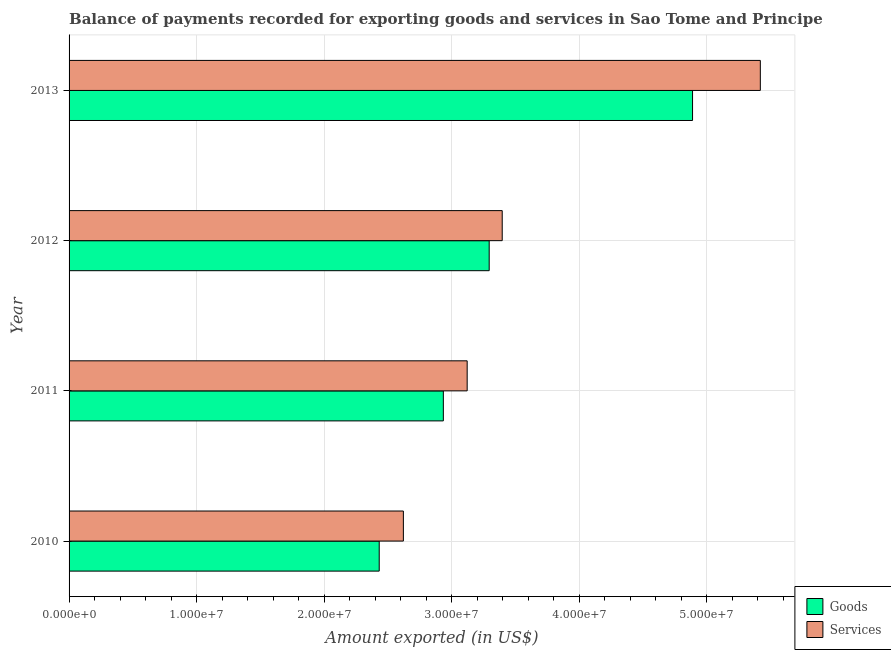How many groups of bars are there?
Provide a succinct answer. 4. Are the number of bars on each tick of the Y-axis equal?
Provide a short and direct response. Yes. How many bars are there on the 4th tick from the top?
Offer a very short reply. 2. How many bars are there on the 4th tick from the bottom?
Provide a short and direct response. 2. What is the label of the 3rd group of bars from the top?
Make the answer very short. 2011. In how many cases, is the number of bars for a given year not equal to the number of legend labels?
Keep it short and to the point. 0. What is the amount of goods exported in 2013?
Offer a very short reply. 4.89e+07. Across all years, what is the maximum amount of goods exported?
Your response must be concise. 4.89e+07. Across all years, what is the minimum amount of goods exported?
Your response must be concise. 2.43e+07. In which year was the amount of goods exported minimum?
Your response must be concise. 2010. What is the total amount of services exported in the graph?
Your response must be concise. 1.46e+08. What is the difference between the amount of services exported in 2010 and that in 2011?
Your answer should be compact. -5.00e+06. What is the difference between the amount of goods exported in 2013 and the amount of services exported in 2011?
Provide a succinct answer. 1.77e+07. What is the average amount of goods exported per year?
Ensure brevity in your answer.  3.39e+07. In the year 2011, what is the difference between the amount of goods exported and amount of services exported?
Provide a succinct answer. -1.87e+06. In how many years, is the amount of services exported greater than 18000000 US$?
Give a very brief answer. 4. What is the ratio of the amount of services exported in 2011 to that in 2012?
Offer a terse response. 0.92. Is the difference between the amount of goods exported in 2010 and 2011 greater than the difference between the amount of services exported in 2010 and 2011?
Your answer should be compact. No. What is the difference between the highest and the second highest amount of services exported?
Your answer should be compact. 2.02e+07. What is the difference between the highest and the lowest amount of goods exported?
Make the answer very short. 2.46e+07. Is the sum of the amount of goods exported in 2010 and 2011 greater than the maximum amount of services exported across all years?
Make the answer very short. No. What does the 2nd bar from the top in 2013 represents?
Make the answer very short. Goods. What does the 2nd bar from the bottom in 2013 represents?
Your answer should be very brief. Services. Are all the bars in the graph horizontal?
Make the answer very short. Yes. What is the difference between two consecutive major ticks on the X-axis?
Ensure brevity in your answer.  1.00e+07. Are the values on the major ticks of X-axis written in scientific E-notation?
Offer a very short reply. Yes. Does the graph contain grids?
Ensure brevity in your answer.  Yes. Where does the legend appear in the graph?
Ensure brevity in your answer.  Bottom right. What is the title of the graph?
Keep it short and to the point. Balance of payments recorded for exporting goods and services in Sao Tome and Principe. Does "Drinking water services" appear as one of the legend labels in the graph?
Offer a terse response. No. What is the label or title of the X-axis?
Keep it short and to the point. Amount exported (in US$). What is the Amount exported (in US$) in Goods in 2010?
Give a very brief answer. 2.43e+07. What is the Amount exported (in US$) in Services in 2010?
Your answer should be very brief. 2.62e+07. What is the Amount exported (in US$) in Goods in 2011?
Offer a very short reply. 2.93e+07. What is the Amount exported (in US$) of Services in 2011?
Offer a very short reply. 3.12e+07. What is the Amount exported (in US$) in Goods in 2012?
Offer a terse response. 3.29e+07. What is the Amount exported (in US$) of Services in 2012?
Your answer should be compact. 3.40e+07. What is the Amount exported (in US$) of Goods in 2013?
Ensure brevity in your answer.  4.89e+07. What is the Amount exported (in US$) in Services in 2013?
Your answer should be very brief. 5.42e+07. Across all years, what is the maximum Amount exported (in US$) of Goods?
Make the answer very short. 4.89e+07. Across all years, what is the maximum Amount exported (in US$) of Services?
Your response must be concise. 5.42e+07. Across all years, what is the minimum Amount exported (in US$) of Goods?
Give a very brief answer. 2.43e+07. Across all years, what is the minimum Amount exported (in US$) in Services?
Provide a short and direct response. 2.62e+07. What is the total Amount exported (in US$) of Goods in the graph?
Your answer should be very brief. 1.35e+08. What is the total Amount exported (in US$) in Services in the graph?
Your answer should be compact. 1.46e+08. What is the difference between the Amount exported (in US$) of Goods in 2010 and that in 2011?
Provide a succinct answer. -5.03e+06. What is the difference between the Amount exported (in US$) of Services in 2010 and that in 2011?
Offer a terse response. -5.00e+06. What is the difference between the Amount exported (in US$) of Goods in 2010 and that in 2012?
Keep it short and to the point. -8.62e+06. What is the difference between the Amount exported (in US$) of Services in 2010 and that in 2012?
Offer a very short reply. -7.75e+06. What is the difference between the Amount exported (in US$) of Goods in 2010 and that in 2013?
Your answer should be compact. -2.46e+07. What is the difference between the Amount exported (in US$) in Services in 2010 and that in 2013?
Offer a terse response. -2.80e+07. What is the difference between the Amount exported (in US$) in Goods in 2011 and that in 2012?
Your response must be concise. -3.59e+06. What is the difference between the Amount exported (in US$) in Services in 2011 and that in 2012?
Offer a terse response. -2.75e+06. What is the difference between the Amount exported (in US$) in Goods in 2011 and that in 2013?
Give a very brief answer. -1.95e+07. What is the difference between the Amount exported (in US$) in Services in 2011 and that in 2013?
Ensure brevity in your answer.  -2.30e+07. What is the difference between the Amount exported (in US$) of Goods in 2012 and that in 2013?
Make the answer very short. -1.59e+07. What is the difference between the Amount exported (in US$) in Services in 2012 and that in 2013?
Keep it short and to the point. -2.02e+07. What is the difference between the Amount exported (in US$) of Goods in 2010 and the Amount exported (in US$) of Services in 2011?
Provide a short and direct response. -6.90e+06. What is the difference between the Amount exported (in US$) of Goods in 2010 and the Amount exported (in US$) of Services in 2012?
Give a very brief answer. -9.64e+06. What is the difference between the Amount exported (in US$) of Goods in 2010 and the Amount exported (in US$) of Services in 2013?
Ensure brevity in your answer.  -2.99e+07. What is the difference between the Amount exported (in US$) of Goods in 2011 and the Amount exported (in US$) of Services in 2012?
Offer a terse response. -4.61e+06. What is the difference between the Amount exported (in US$) of Goods in 2011 and the Amount exported (in US$) of Services in 2013?
Make the answer very short. -2.48e+07. What is the difference between the Amount exported (in US$) in Goods in 2012 and the Amount exported (in US$) in Services in 2013?
Provide a succinct answer. -2.13e+07. What is the average Amount exported (in US$) of Goods per year?
Provide a short and direct response. 3.39e+07. What is the average Amount exported (in US$) in Services per year?
Your answer should be very brief. 3.64e+07. In the year 2010, what is the difference between the Amount exported (in US$) in Goods and Amount exported (in US$) in Services?
Keep it short and to the point. -1.89e+06. In the year 2011, what is the difference between the Amount exported (in US$) in Goods and Amount exported (in US$) in Services?
Offer a terse response. -1.87e+06. In the year 2012, what is the difference between the Amount exported (in US$) of Goods and Amount exported (in US$) of Services?
Your response must be concise. -1.02e+06. In the year 2013, what is the difference between the Amount exported (in US$) of Goods and Amount exported (in US$) of Services?
Your answer should be very brief. -5.31e+06. What is the ratio of the Amount exported (in US$) in Goods in 2010 to that in 2011?
Offer a very short reply. 0.83. What is the ratio of the Amount exported (in US$) of Services in 2010 to that in 2011?
Provide a short and direct response. 0.84. What is the ratio of the Amount exported (in US$) in Goods in 2010 to that in 2012?
Your response must be concise. 0.74. What is the ratio of the Amount exported (in US$) in Services in 2010 to that in 2012?
Your answer should be compact. 0.77. What is the ratio of the Amount exported (in US$) in Goods in 2010 to that in 2013?
Offer a very short reply. 0.5. What is the ratio of the Amount exported (in US$) in Services in 2010 to that in 2013?
Provide a succinct answer. 0.48. What is the ratio of the Amount exported (in US$) in Goods in 2011 to that in 2012?
Ensure brevity in your answer.  0.89. What is the ratio of the Amount exported (in US$) of Services in 2011 to that in 2012?
Provide a succinct answer. 0.92. What is the ratio of the Amount exported (in US$) of Goods in 2011 to that in 2013?
Give a very brief answer. 0.6. What is the ratio of the Amount exported (in US$) of Services in 2011 to that in 2013?
Give a very brief answer. 0.58. What is the ratio of the Amount exported (in US$) in Goods in 2012 to that in 2013?
Keep it short and to the point. 0.67. What is the ratio of the Amount exported (in US$) in Services in 2012 to that in 2013?
Provide a short and direct response. 0.63. What is the difference between the highest and the second highest Amount exported (in US$) of Goods?
Offer a terse response. 1.59e+07. What is the difference between the highest and the second highest Amount exported (in US$) in Services?
Make the answer very short. 2.02e+07. What is the difference between the highest and the lowest Amount exported (in US$) in Goods?
Make the answer very short. 2.46e+07. What is the difference between the highest and the lowest Amount exported (in US$) in Services?
Offer a very short reply. 2.80e+07. 